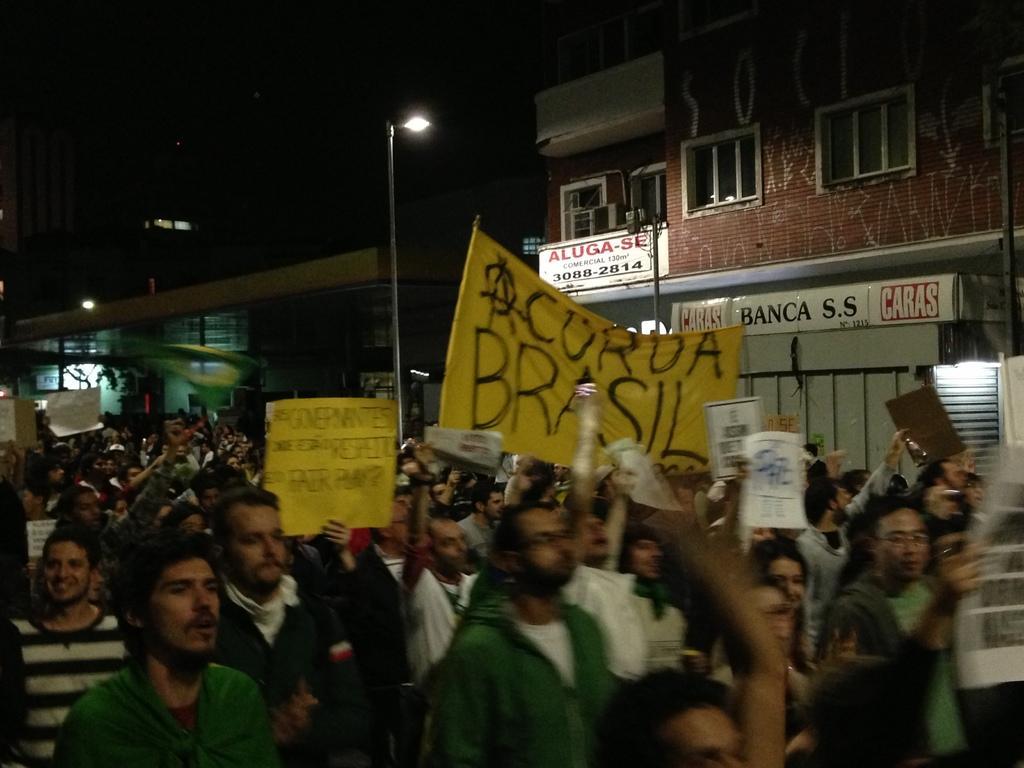Could you give a brief overview of what you see in this image? In this image I can see a group of people waking and few are holding banners and boards. Back I can see light poles,buildings and windows. 